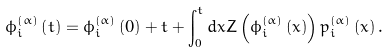Convert formula to latex. <formula><loc_0><loc_0><loc_500><loc_500>\phi _ { i } ^ { \left ( \alpha \right ) } \left ( t \right ) = \phi _ { i } ^ { \left ( \alpha \right ) } \left ( 0 \right ) + t + \int _ { 0 } ^ { t } d x Z \left ( \phi _ { i } ^ { \left ( \alpha \right ) } \left ( x \right ) \right ) p _ { i } ^ { \left ( \alpha \right ) } \left ( x \right ) .</formula> 